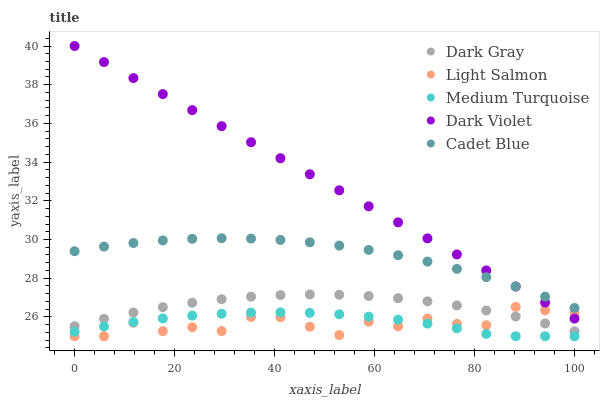Does Light Salmon have the minimum area under the curve?
Answer yes or no. Yes. Does Dark Violet have the maximum area under the curve?
Answer yes or no. Yes. Does Cadet Blue have the minimum area under the curve?
Answer yes or no. No. Does Cadet Blue have the maximum area under the curve?
Answer yes or no. No. Is Dark Violet the smoothest?
Answer yes or no. Yes. Is Light Salmon the roughest?
Answer yes or no. Yes. Is Cadet Blue the smoothest?
Answer yes or no. No. Is Cadet Blue the roughest?
Answer yes or no. No. Does Light Salmon have the lowest value?
Answer yes or no. Yes. Does Cadet Blue have the lowest value?
Answer yes or no. No. Does Dark Violet have the highest value?
Answer yes or no. Yes. Does Light Salmon have the highest value?
Answer yes or no. No. Is Medium Turquoise less than Dark Violet?
Answer yes or no. Yes. Is Dark Violet greater than Dark Gray?
Answer yes or no. Yes. Does Light Salmon intersect Medium Turquoise?
Answer yes or no. Yes. Is Light Salmon less than Medium Turquoise?
Answer yes or no. No. Is Light Salmon greater than Medium Turquoise?
Answer yes or no. No. Does Medium Turquoise intersect Dark Violet?
Answer yes or no. No. 